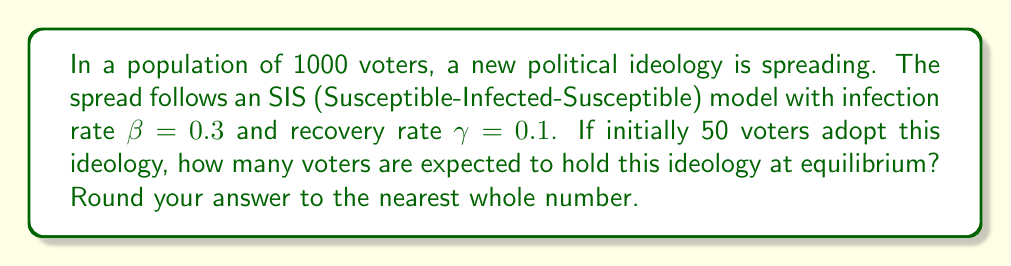Provide a solution to this math problem. To solve this problem, we'll use the SIS model and find the equilibrium state:

1) In the SIS model, the basic reproduction number $R_0$ is given by:
   $$R_0 = \frac{\beta}{\gamma}$$

2) Substituting the given values:
   $$R_0 = \frac{0.3}{0.1} = 3$$

3) The equilibrium proportion of infected (ideology holders) in the SIS model is given by:
   $$i^* = 1 - \frac{1}{R_0}$$
   when $R_0 > 1$, which is true in this case.

4) Substituting $R_0 = 3$:
   $$i^* = 1 - \frac{1}{3} = \frac{2}{3}$$

5) To find the number of ideology holders at equilibrium, multiply by the total population:
   $$\text{Number of ideology holders} = i^* \times \text{Total population}$$
   $$= \frac{2}{3} \times 1000 = 666.67$$

6) Rounding to the nearest whole number:
   $$667 \text{ voters}$$
Answer: 667 voters 